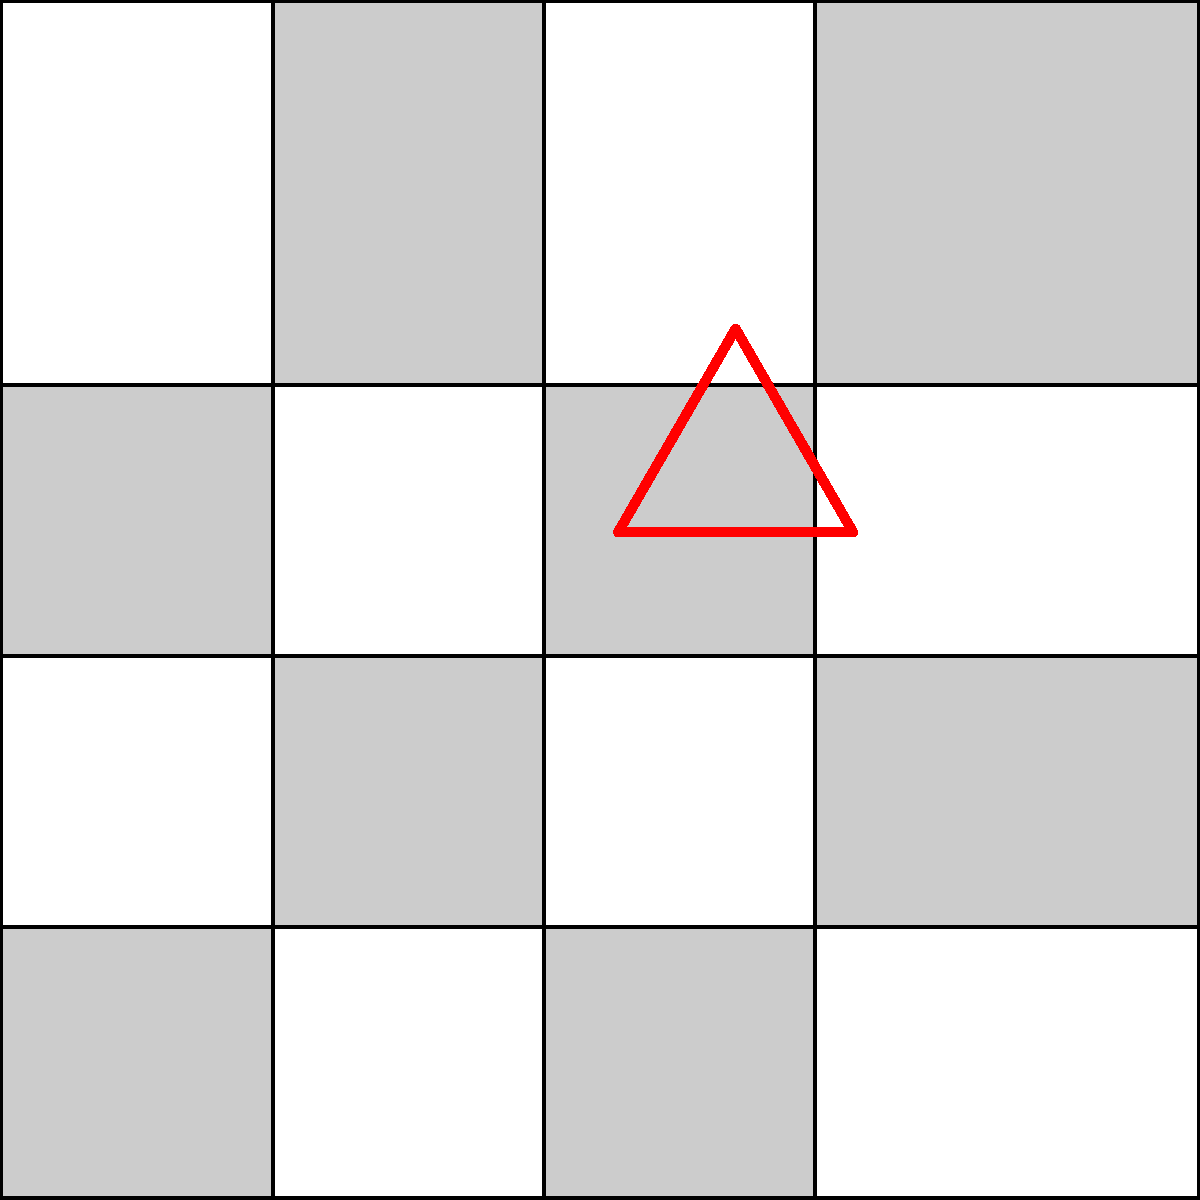In the tessellation shown above, a red equilateral triangle has been superimposed. How many complete squares are covered by this triangle? To solve this problem, let's break it down step-by-step:

1. Observe the tessellation: It consists of a 4x4 grid of alternating light and dark squares.

2. Locate the red equilateral triangle: It's centered at the intersection of four squares in the middle of the grid.

3. Analyze the triangle's position:
   - Its vertices touch the midpoints of three different squares.
   - It covers parts of four squares, but not necessarily complete squares.

4. Consider the properties of an equilateral triangle:
   - All sides are equal in length.
   - All angles are 60°.

5. Examine the coverage of each square:
   - The triangle covers exactly half of each of the four squares it touches.
   - $\frac{1}{2} + \frac{1}{2} = 1$ complete square

6. Count the complete squares:
   - Since the triangle covers half of four squares, this is equivalent to two complete squares.

Therefore, the red equilateral triangle covers the equivalent of 2 complete squares in the tessellation.
Answer: 2 